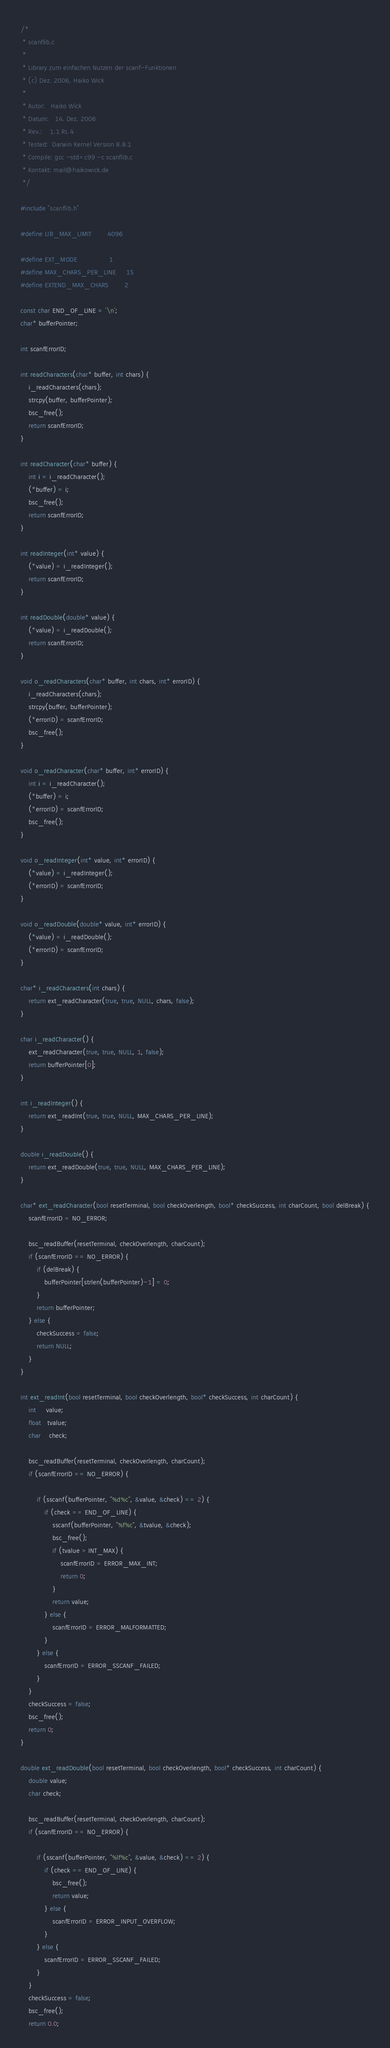Convert code to text. <code><loc_0><loc_0><loc_500><loc_500><_C_>/*
 * scanflib.c
 *
 * Library zum einfachen Nutzen der scanf-Funktionen
 * (c) Dez. 2006, Haiko Wick
 *
 * Autor:   Haiko Wick
 * Datum:   14. Dez. 2006
 * Rev.:    1.1 RL 4
 * Tested:  Darwin Kernel Version 8.8.1
 * Compile: gcc -std=c99 -c scanflib.c
 * Kontakt: mail@haikowick.de
 */

#include "scanflib.h"

#define LIB_MAX_LIMIT        4096

#define EXT_MODE                1
#define MAX_CHARS_PER_LINE     15
#define EXTEND_MAX_CHARS        2

const char END_OF_LINE = '\n';
char* bufferPointer;

int scanfErrorID;

int readCharacters(char* buffer, int chars) {
    i_readCharacters(chars);
    strcpy(buffer, bufferPointer);
    bsc_free();
    return scanfErrorID;
}

int readCharacter(char* buffer) {
    int i = i_readCharacter();
    (*buffer) = i;
    bsc_free();
    return scanfErrorID;
}

int readInteger(int* value) {
    (*value) = i_readInteger();
    return scanfErrorID;
}

int readDouble(double* value) {
    (*value) = i_readDouble();
    return scanfErrorID;    
}

void o_readCharacters(char* buffer, int chars, int* errorID) {
    i_readCharacters(chars);
    strcpy(buffer, bufferPointer);
    (*errorID) = scanfErrorID;
    bsc_free();
}

void o_readCharacter(char* buffer, int* errorID) {
    int i = i_readCharacter();
    (*buffer) = i;
    (*errorID) = scanfErrorID;
    bsc_free();
}

void o_readInteger(int* value, int* errorID) {
    (*value) = i_readInteger();
    (*errorID) = scanfErrorID;
}

void o_readDouble(double* value, int* errorID) {
    (*value) = i_readDouble();
    (*errorID) = scanfErrorID;    
}

char* i_readCharacters(int chars) {
    return ext_readCharacter(true, true, NULL, chars, false);
}

char i_readCharacter() {
	ext_readCharacter(true, true, NULL, 1, false);
	return bufferPointer[0];
}

int i_readInteger() {
	return ext_readInt(true, true, NULL, MAX_CHARS_PER_LINE);
}

double i_readDouble() {
	return ext_readDouble(true, true, NULL, MAX_CHARS_PER_LINE);
}

char* ext_readCharacter(bool resetTerminal, bool checkOverlength, bool* checkSuccess, int charCount, bool delBreak) {
    scanfErrorID = NO_ERROR;
    
    bsc_readBuffer(resetTerminal, checkOverlength, charCount);
    if (scanfErrorID == NO_ERROR) {
        if (delBreak) {
            bufferPointer[strlen(bufferPointer)-1] = 0;
        }
        return bufferPointer;
    } else {
        checkSuccess = false;
        return NULL;
    }
}

int ext_readInt(bool resetTerminal, bool checkOverlength, bool* checkSuccess, int charCount) {
    int     value;
    float   tvalue;
    char    check;
    
	bsc_readBuffer(resetTerminal, checkOverlength, charCount);
    if (scanfErrorID == NO_ERROR) {
        
        if (sscanf(bufferPointer, "%d%c", &value, &check) == 2) {
            if (check == END_OF_LINE) {
                sscanf(bufferPointer, "%f%c", &tvalue, &check);
                bsc_free();                
                if (tvalue > INT_MAX) {
                    scanfErrorID = ERROR_MAX_INT;
                    return 0;
                }
                return value;
            } else {
                scanfErrorID = ERROR_MALFORMATTED;
            }
        } else {
            scanfErrorID = ERROR_SSCANF_FAILED;
        }
    }
    checkSuccess = false;
    bsc_free();
    return 0;
}

double ext_readDouble(bool resetTerminal, bool checkOverlength, bool* checkSuccess, int charCount) {
    double value;
    char check;
    
	bsc_readBuffer(resetTerminal, checkOverlength, charCount);
    if (scanfErrorID == NO_ERROR) {
        
        if (sscanf(bufferPointer, "%lf%c", &value, &check) == 2) {
            if (check == END_OF_LINE) {
                bsc_free();
                return value;
            } else {
                scanfErrorID = ERROR_INPUT_OVERFLOW;
            }
        } else {
            scanfErrorID = ERROR_SSCANF_FAILED;
        }
    }
    checkSuccess = false;
    bsc_free();
    return 0.0;</code> 